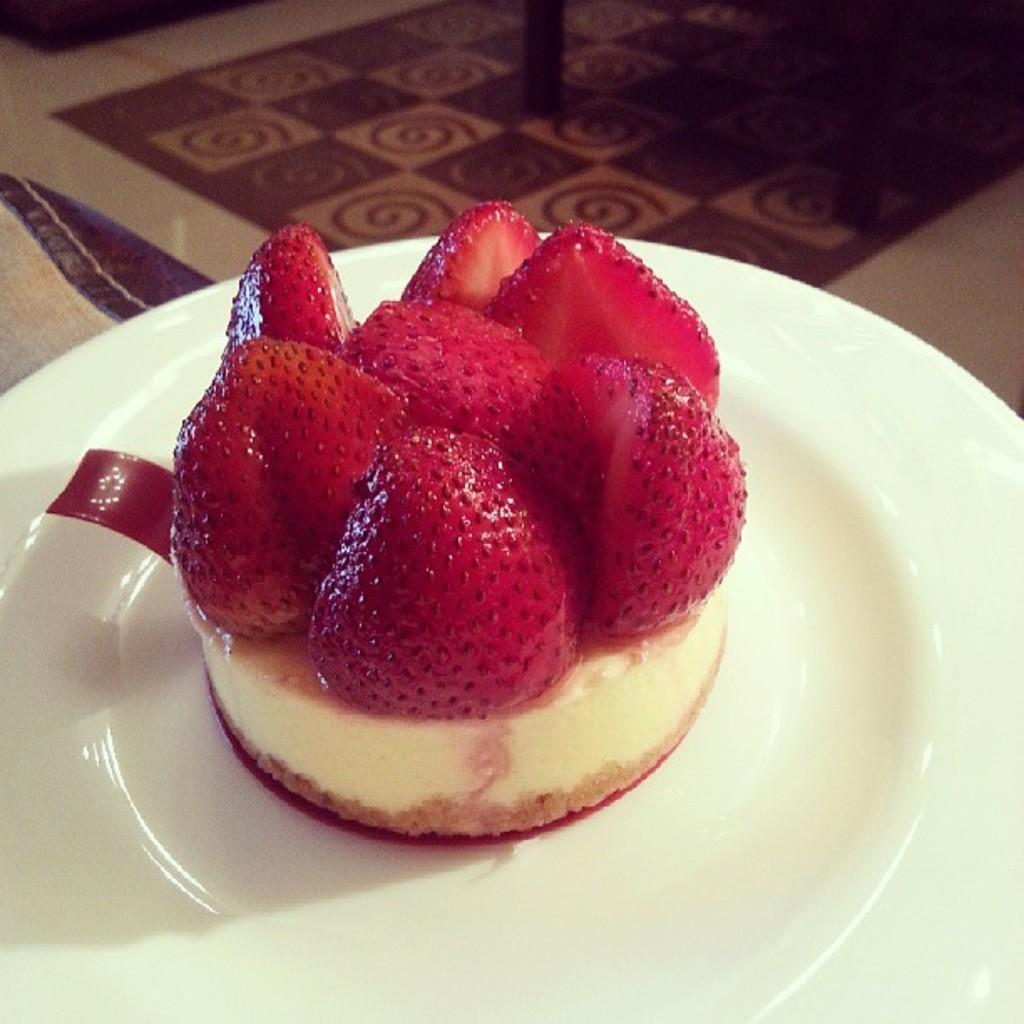What type of food is visible in the image? There is food in the image, and it has strawberries on it. How is the food arranged or presented in the image? The food is placed on a plate in the image. What color is the plate that the food is on? The plate is white. Can you tell me which actor is featured in the image? There is no actor present in the image; it features food with strawberries on a white plate. What type of coastline can be seen in the image? There is no coastline visible in the image; it features food with strawberries on a white plate. 